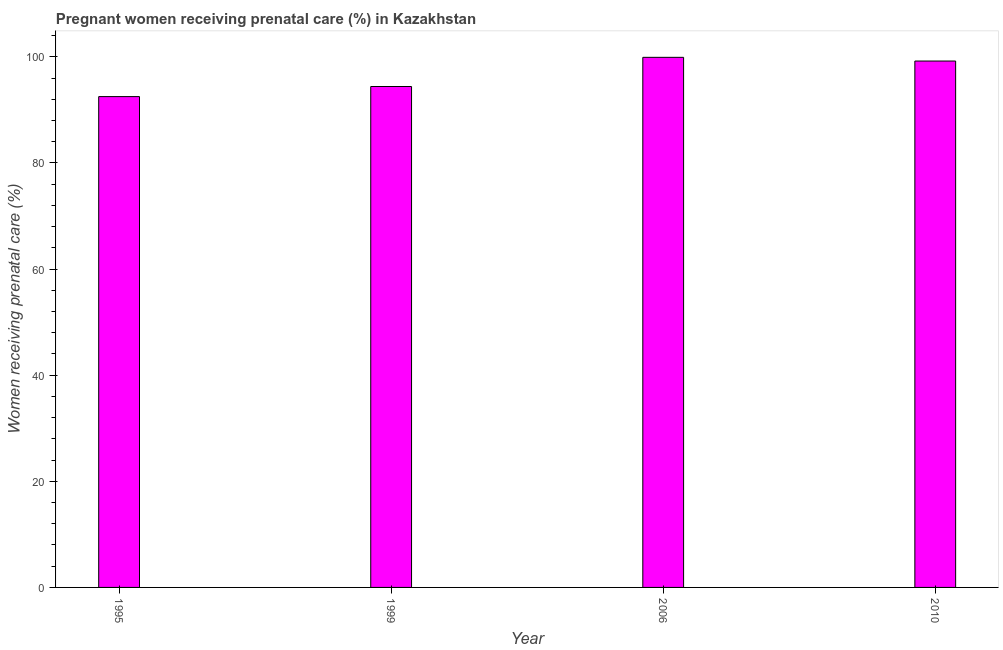Does the graph contain any zero values?
Your answer should be compact. No. What is the title of the graph?
Make the answer very short. Pregnant women receiving prenatal care (%) in Kazakhstan. What is the label or title of the X-axis?
Make the answer very short. Year. What is the label or title of the Y-axis?
Your answer should be very brief. Women receiving prenatal care (%). What is the percentage of pregnant women receiving prenatal care in 1995?
Make the answer very short. 92.5. Across all years, what is the maximum percentage of pregnant women receiving prenatal care?
Your answer should be compact. 99.9. Across all years, what is the minimum percentage of pregnant women receiving prenatal care?
Provide a short and direct response. 92.5. In which year was the percentage of pregnant women receiving prenatal care maximum?
Ensure brevity in your answer.  2006. What is the sum of the percentage of pregnant women receiving prenatal care?
Give a very brief answer. 386. What is the average percentage of pregnant women receiving prenatal care per year?
Your answer should be compact. 96.5. What is the median percentage of pregnant women receiving prenatal care?
Your answer should be compact. 96.8. Do a majority of the years between 1995 and 2006 (inclusive) have percentage of pregnant women receiving prenatal care greater than 84 %?
Ensure brevity in your answer.  Yes. What is the ratio of the percentage of pregnant women receiving prenatal care in 1995 to that in 2010?
Keep it short and to the point. 0.93. Is the percentage of pregnant women receiving prenatal care in 1995 less than that in 1999?
Your response must be concise. Yes. Is the difference between the percentage of pregnant women receiving prenatal care in 2006 and 2010 greater than the difference between any two years?
Offer a very short reply. No. What is the difference between the highest and the second highest percentage of pregnant women receiving prenatal care?
Offer a terse response. 0.7. Is the sum of the percentage of pregnant women receiving prenatal care in 1995 and 1999 greater than the maximum percentage of pregnant women receiving prenatal care across all years?
Keep it short and to the point. Yes. What is the difference between the highest and the lowest percentage of pregnant women receiving prenatal care?
Make the answer very short. 7.4. In how many years, is the percentage of pregnant women receiving prenatal care greater than the average percentage of pregnant women receiving prenatal care taken over all years?
Provide a succinct answer. 2. What is the difference between two consecutive major ticks on the Y-axis?
Make the answer very short. 20. Are the values on the major ticks of Y-axis written in scientific E-notation?
Make the answer very short. No. What is the Women receiving prenatal care (%) of 1995?
Provide a short and direct response. 92.5. What is the Women receiving prenatal care (%) in 1999?
Offer a terse response. 94.4. What is the Women receiving prenatal care (%) of 2006?
Ensure brevity in your answer.  99.9. What is the Women receiving prenatal care (%) in 2010?
Provide a succinct answer. 99.2. What is the difference between the Women receiving prenatal care (%) in 1999 and 2006?
Offer a very short reply. -5.5. What is the difference between the Women receiving prenatal care (%) in 1999 and 2010?
Your response must be concise. -4.8. What is the difference between the Women receiving prenatal care (%) in 2006 and 2010?
Offer a very short reply. 0.7. What is the ratio of the Women receiving prenatal care (%) in 1995 to that in 2006?
Provide a short and direct response. 0.93. What is the ratio of the Women receiving prenatal care (%) in 1995 to that in 2010?
Your response must be concise. 0.93. What is the ratio of the Women receiving prenatal care (%) in 1999 to that in 2006?
Ensure brevity in your answer.  0.94. 